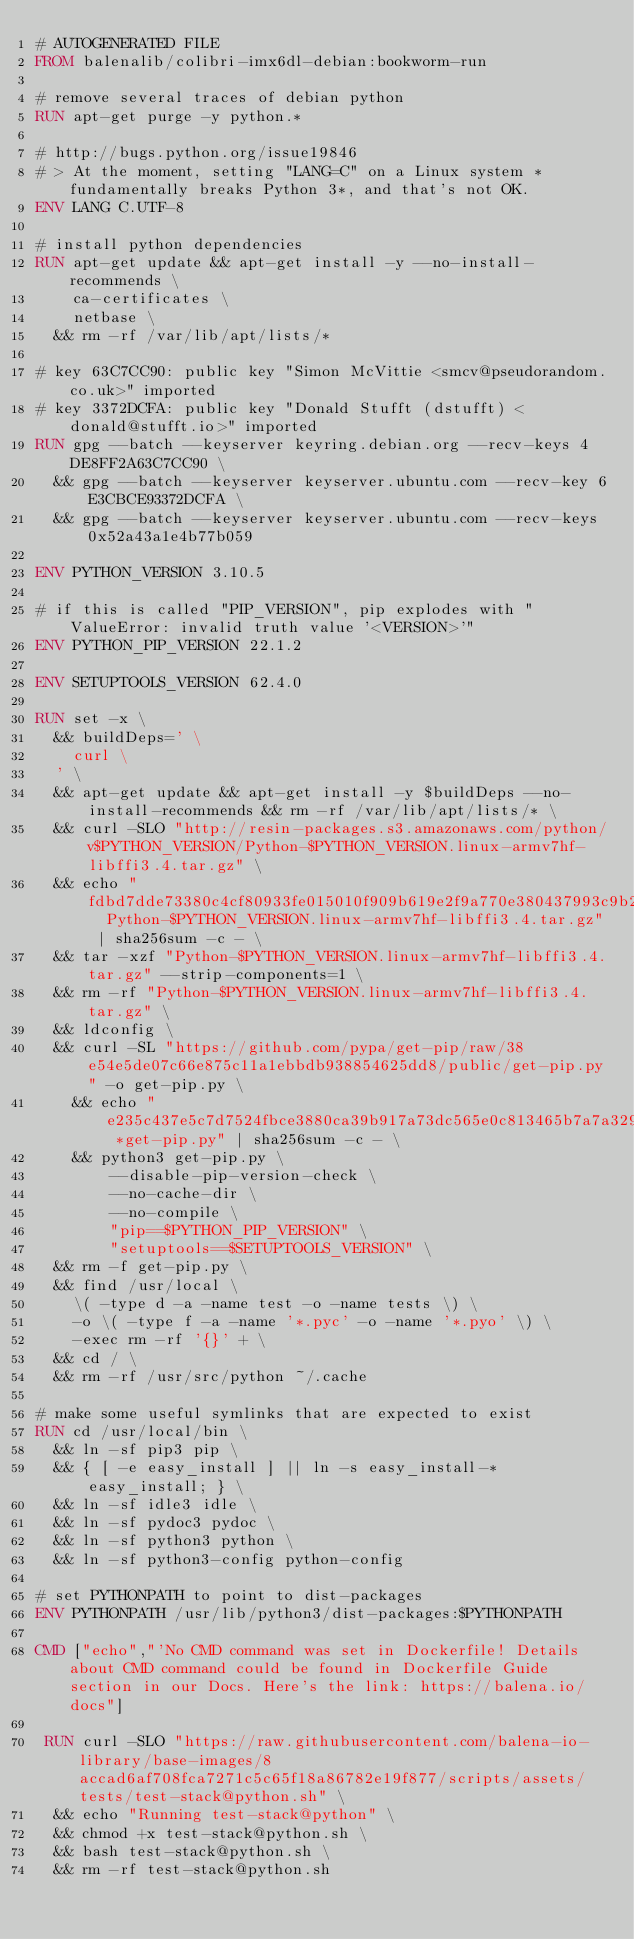Convert code to text. <code><loc_0><loc_0><loc_500><loc_500><_Dockerfile_># AUTOGENERATED FILE
FROM balenalib/colibri-imx6dl-debian:bookworm-run

# remove several traces of debian python
RUN apt-get purge -y python.*

# http://bugs.python.org/issue19846
# > At the moment, setting "LANG=C" on a Linux system *fundamentally breaks Python 3*, and that's not OK.
ENV LANG C.UTF-8

# install python dependencies
RUN apt-get update && apt-get install -y --no-install-recommends \
		ca-certificates \
		netbase \
	&& rm -rf /var/lib/apt/lists/*

# key 63C7CC90: public key "Simon McVittie <smcv@pseudorandom.co.uk>" imported
# key 3372DCFA: public key "Donald Stufft (dstufft) <donald@stufft.io>" imported
RUN gpg --batch --keyserver keyring.debian.org --recv-keys 4DE8FF2A63C7CC90 \
	&& gpg --batch --keyserver keyserver.ubuntu.com --recv-key 6E3CBCE93372DCFA \
	&& gpg --batch --keyserver keyserver.ubuntu.com --recv-keys 0x52a43a1e4b77b059

ENV PYTHON_VERSION 3.10.5

# if this is called "PIP_VERSION", pip explodes with "ValueError: invalid truth value '<VERSION>'"
ENV PYTHON_PIP_VERSION 22.1.2

ENV SETUPTOOLS_VERSION 62.4.0

RUN set -x \
	&& buildDeps=' \
		curl \
	' \
	&& apt-get update && apt-get install -y $buildDeps --no-install-recommends && rm -rf /var/lib/apt/lists/* \
	&& curl -SLO "http://resin-packages.s3.amazonaws.com/python/v$PYTHON_VERSION/Python-$PYTHON_VERSION.linux-armv7hf-libffi3.4.tar.gz" \
	&& echo "fdbd7dde73380c4cf80933fe015010f909b619e2f9a770e380437993c9b265ab  Python-$PYTHON_VERSION.linux-armv7hf-libffi3.4.tar.gz" | sha256sum -c - \
	&& tar -xzf "Python-$PYTHON_VERSION.linux-armv7hf-libffi3.4.tar.gz" --strip-components=1 \
	&& rm -rf "Python-$PYTHON_VERSION.linux-armv7hf-libffi3.4.tar.gz" \
	&& ldconfig \
	&& curl -SL "https://github.com/pypa/get-pip/raw/38e54e5de07c66e875c11a1ebbdb938854625dd8/public/get-pip.py" -o get-pip.py \
    && echo "e235c437e5c7d7524fbce3880ca39b917a73dc565e0c813465b7a7a329bb279a *get-pip.py" | sha256sum -c - \
    && python3 get-pip.py \
        --disable-pip-version-check \
        --no-cache-dir \
        --no-compile \
        "pip==$PYTHON_PIP_VERSION" \
        "setuptools==$SETUPTOOLS_VERSION" \
	&& rm -f get-pip.py \
	&& find /usr/local \
		\( -type d -a -name test -o -name tests \) \
		-o \( -type f -a -name '*.pyc' -o -name '*.pyo' \) \
		-exec rm -rf '{}' + \
	&& cd / \
	&& rm -rf /usr/src/python ~/.cache

# make some useful symlinks that are expected to exist
RUN cd /usr/local/bin \
	&& ln -sf pip3 pip \
	&& { [ -e easy_install ] || ln -s easy_install-* easy_install; } \
	&& ln -sf idle3 idle \
	&& ln -sf pydoc3 pydoc \
	&& ln -sf python3 python \
	&& ln -sf python3-config python-config

# set PYTHONPATH to point to dist-packages
ENV PYTHONPATH /usr/lib/python3/dist-packages:$PYTHONPATH

CMD ["echo","'No CMD command was set in Dockerfile! Details about CMD command could be found in Dockerfile Guide section in our Docs. Here's the link: https://balena.io/docs"]

 RUN curl -SLO "https://raw.githubusercontent.com/balena-io-library/base-images/8accad6af708fca7271c5c65f18a86782e19f877/scripts/assets/tests/test-stack@python.sh" \
  && echo "Running test-stack@python" \
  && chmod +x test-stack@python.sh \
  && bash test-stack@python.sh \
  && rm -rf test-stack@python.sh 
</code> 